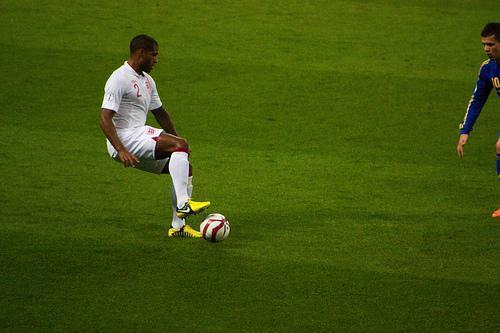How many balls are there?
Give a very brief answer. 1. 